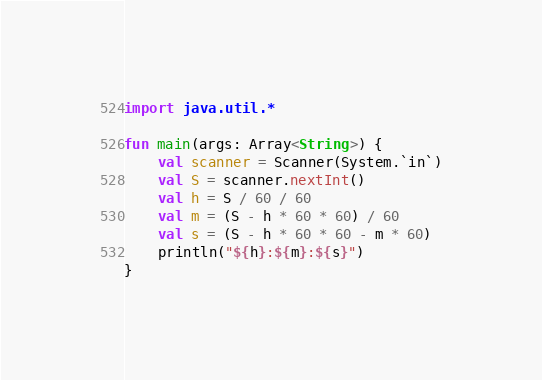<code> <loc_0><loc_0><loc_500><loc_500><_Kotlin_>import java.util.*

fun main(args: Array<String>) {
    val scanner = Scanner(System.`in`)
    val S = scanner.nextInt()
    val h = S / 60 / 60
    val m = (S - h * 60 * 60) / 60
    val s = (S - h * 60 * 60 - m * 60)
    println("${h}:${m}:${s}")
}
</code> 